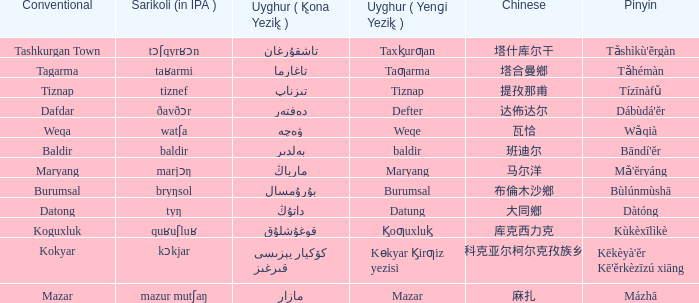What would be the uyghur equivalent for 瓦恰? ۋەچە. 